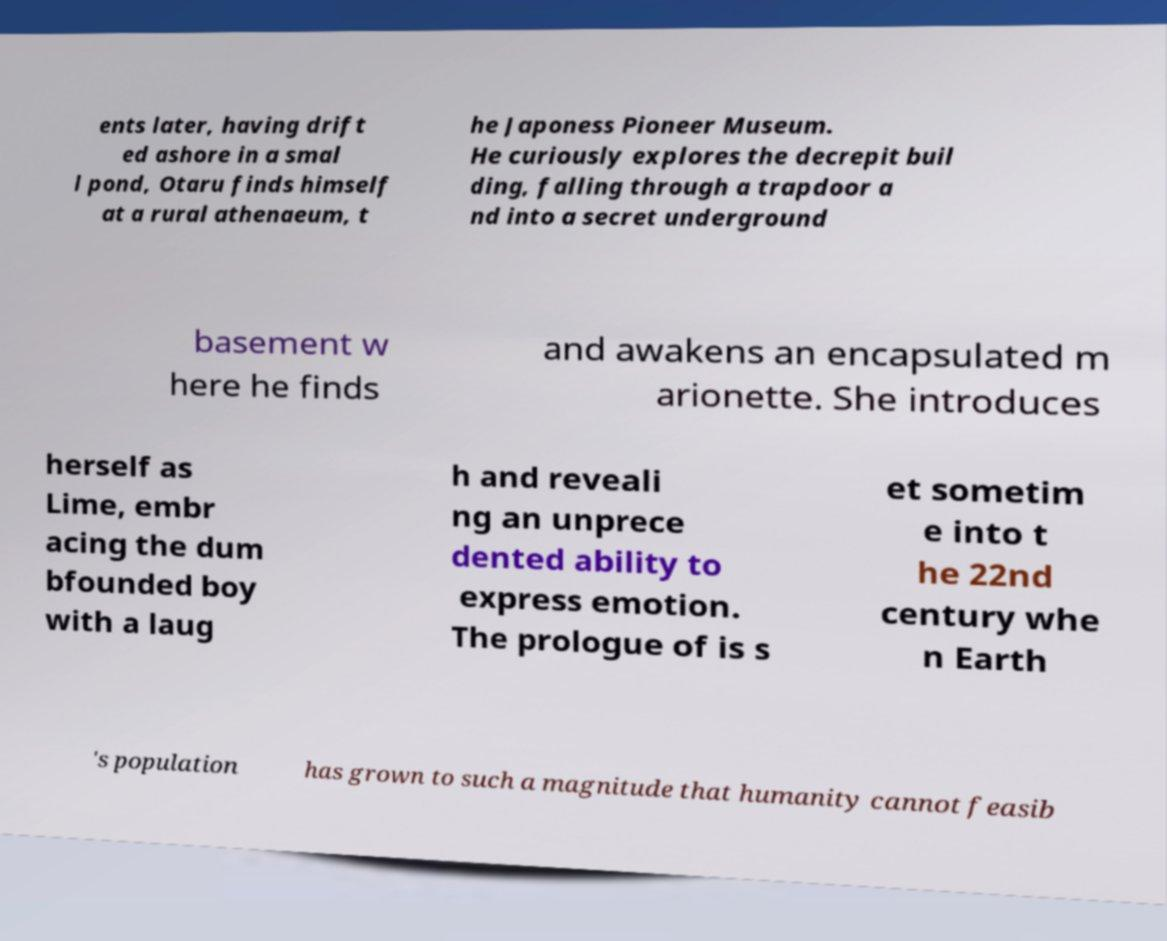Can you accurately transcribe the text from the provided image for me? ents later, having drift ed ashore in a smal l pond, Otaru finds himself at a rural athenaeum, t he Japoness Pioneer Museum. He curiously explores the decrepit buil ding, falling through a trapdoor a nd into a secret underground basement w here he finds and awakens an encapsulated m arionette. She introduces herself as Lime, embr acing the dum bfounded boy with a laug h and reveali ng an unprece dented ability to express emotion. The prologue of is s et sometim e into t he 22nd century whe n Earth 's population has grown to such a magnitude that humanity cannot feasib 